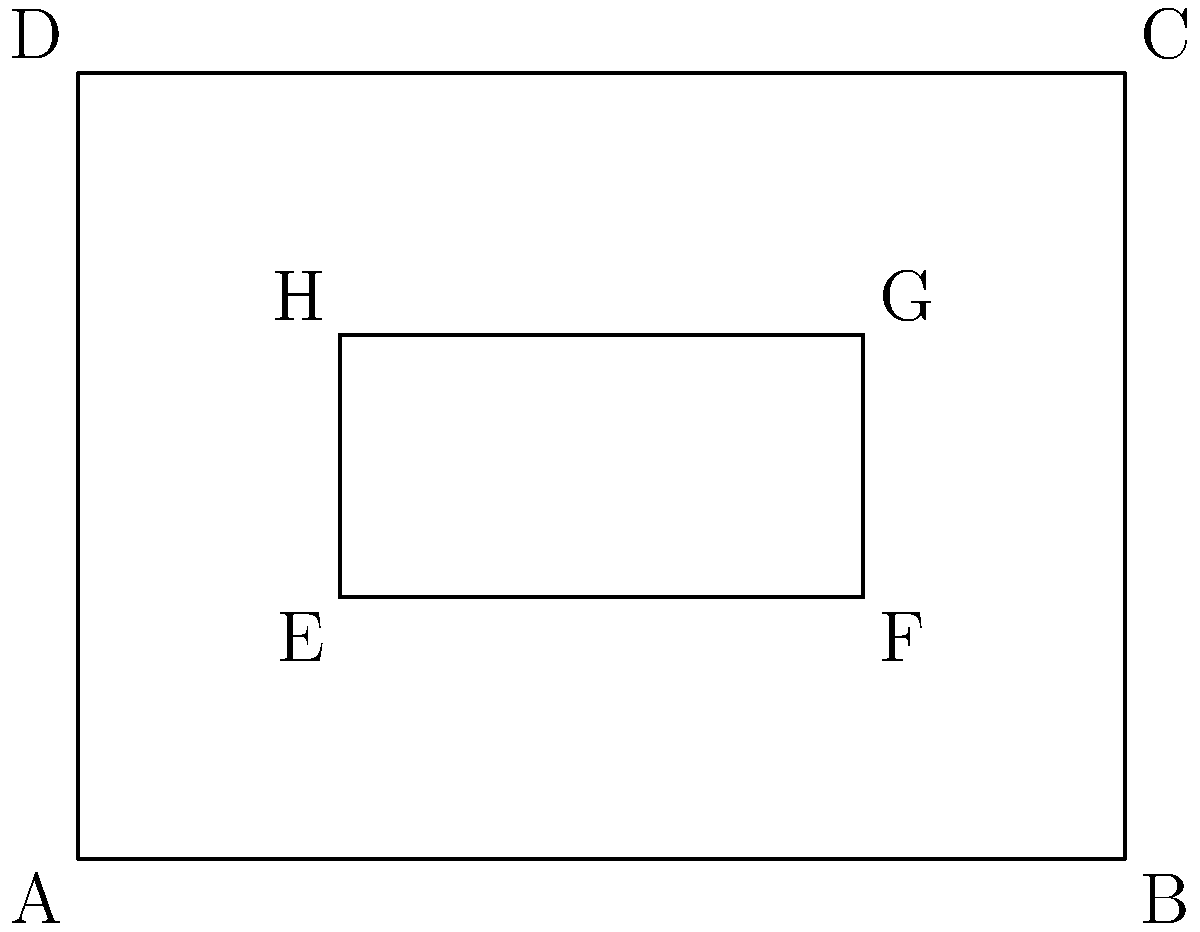In designing a user interface for a web-based game using Unreal Engine integrated with HTML, you need to create congruent rectangular buttons. The outer rectangle ABCD represents the game window, and the inner rectangle EFGH represents a button. If AB = 4 units and BC = 3 units, what should be the dimensions of EFGH to ensure it's exactly 25% of the area of ABCD while maintaining the same aspect ratio? To solve this problem, we'll follow these steps:

1) First, calculate the area of the outer rectangle ABCD:
   Area of ABCD = $4 * 3 = 12$ square units

2) The inner rectangle EFGH should be 25% of this area:
   Area of EFGH = $25\% * 12 = 0.25 * 12 = 3$ square units

3) To maintain the same aspect ratio, the ratio of width to height should be the same for both rectangles:
   $\frac{width}{height} = \frac{4}{3}$

4) Let's say the width of EFGH is $x$. Then its height would be $\frac{3x}{4}$ to maintain the aspect ratio.

5) The area of EFGH should be 3 square units:
   $x * \frac{3x}{4} = 3$
   $\frac{3x^2}{4} = 3$
   $x^2 = 4$
   $x = 2$

6) So, the width of EFGH is 2 units, and its height is:
   $\frac{3 * 2}{4} = 1.5$ units

7) To verify:
   Area of EFGH = $2 * 1.5 = 3$ square units, which is 25% of 12

Therefore, the dimensions of EFGH should be 2 units wide and 1.5 units high.
Answer: 2 units by 1.5 units 